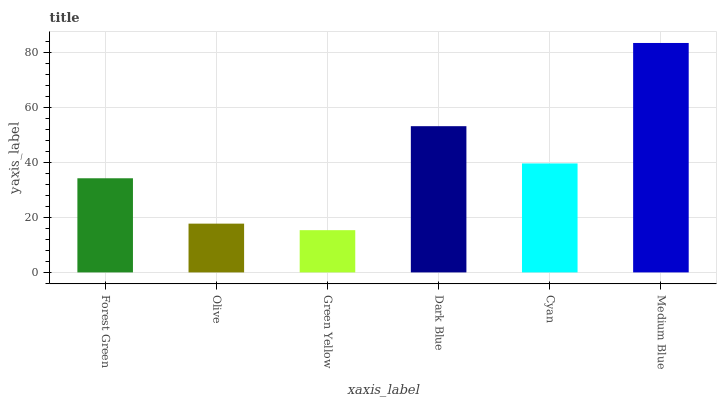Is Green Yellow the minimum?
Answer yes or no. Yes. Is Medium Blue the maximum?
Answer yes or no. Yes. Is Olive the minimum?
Answer yes or no. No. Is Olive the maximum?
Answer yes or no. No. Is Forest Green greater than Olive?
Answer yes or no. Yes. Is Olive less than Forest Green?
Answer yes or no. Yes. Is Olive greater than Forest Green?
Answer yes or no. No. Is Forest Green less than Olive?
Answer yes or no. No. Is Cyan the high median?
Answer yes or no. Yes. Is Forest Green the low median?
Answer yes or no. Yes. Is Olive the high median?
Answer yes or no. No. Is Olive the low median?
Answer yes or no. No. 